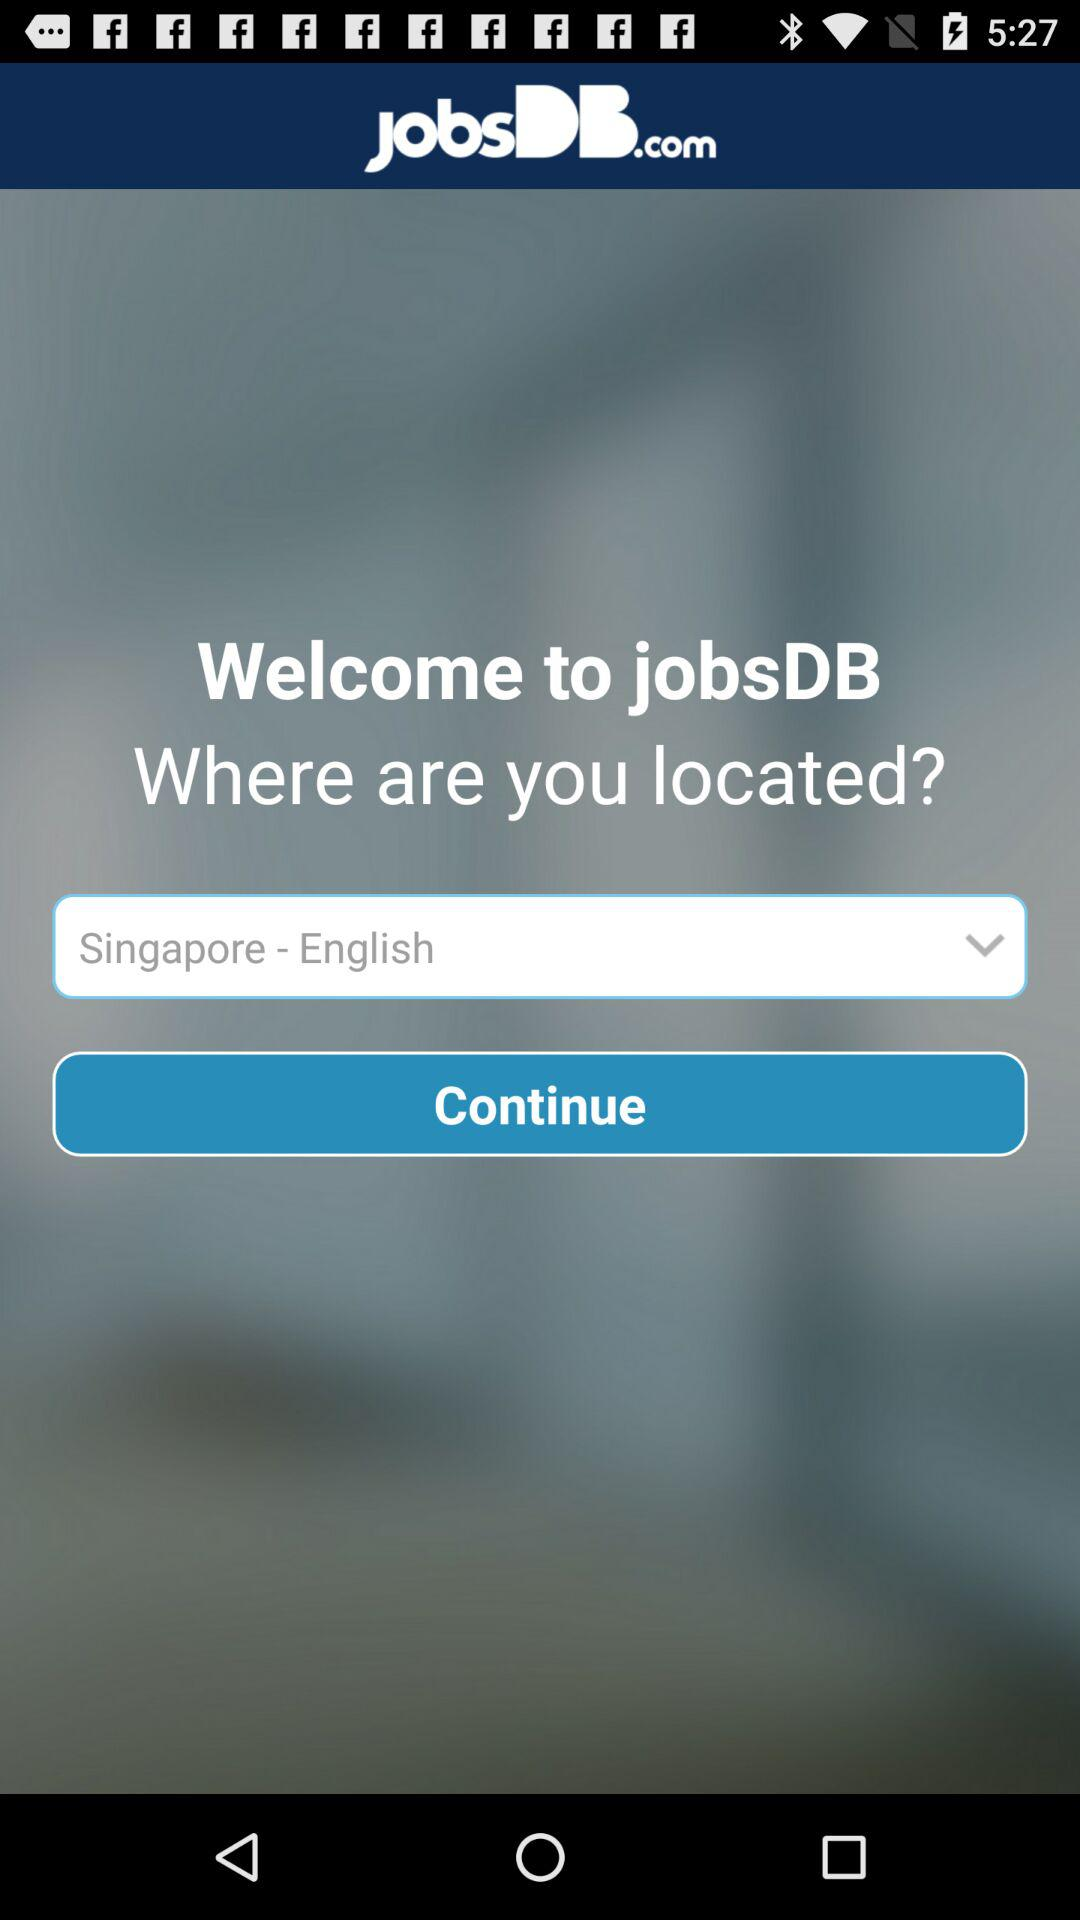Which location is selected? The selected location is Singapore. 